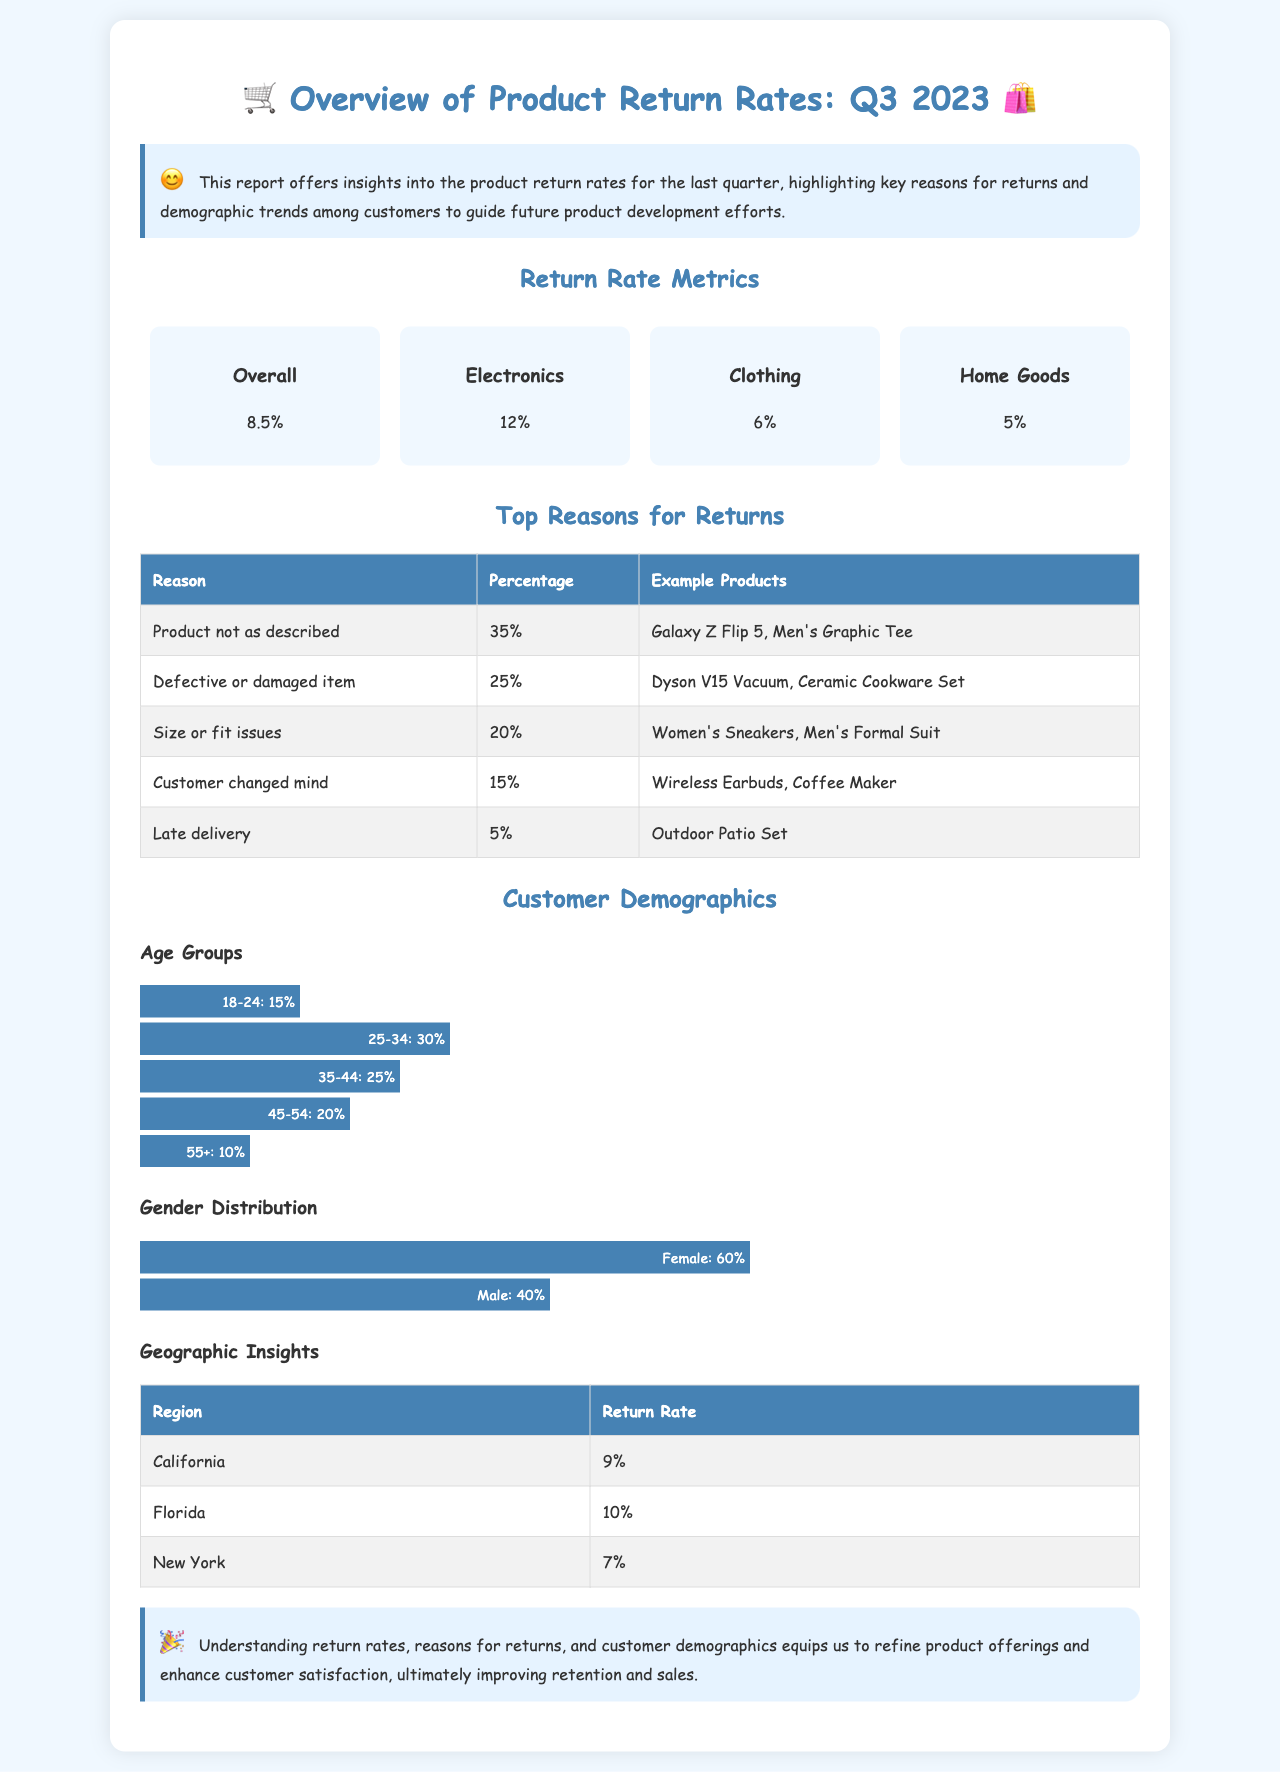What is the overall return rate for Q3 2023? The overall return rate is presented in the metrics section, which indicates 8.5%.
Answer: 8.5% What percentage of returns are due to defective or damaged items? The document lists the reasons for returns in a table, showing that 25% of returns are attributed to defective or damaged items.
Answer: 25% What age group has the highest percentage of returns? By analyzing the age distribution chart, the 25-34 age group accounts for the largest share of 30%.
Answer: 25-34 Which category of products has the highest return rate? The return rates for product categories indicate that Electronics has the highest return rate at 12%.
Answer: 12% What is the return rate for customers in Florida? The geographic insights table shows that the return rate for Florida is 10%.
Answer: 10% What is one example product for returns due to size or fit issues? The document provides an example of a return reason, listing Men's Formal Suit under size or fit issues.
Answer: Men's Formal Suit What gender has the majority of returns? The gender distribution chart indicates that Female customers represent 60% of the demographic.
Answer: Female What was the return rate for Clothing items? The metrics section specifies that the return rate for Clothing is 6%.
Answer: 6% What percentage of returns were due to customers changing their minds? The reasons for returns table shows that 15% of returns were due to customers changing their minds.
Answer: 15% 